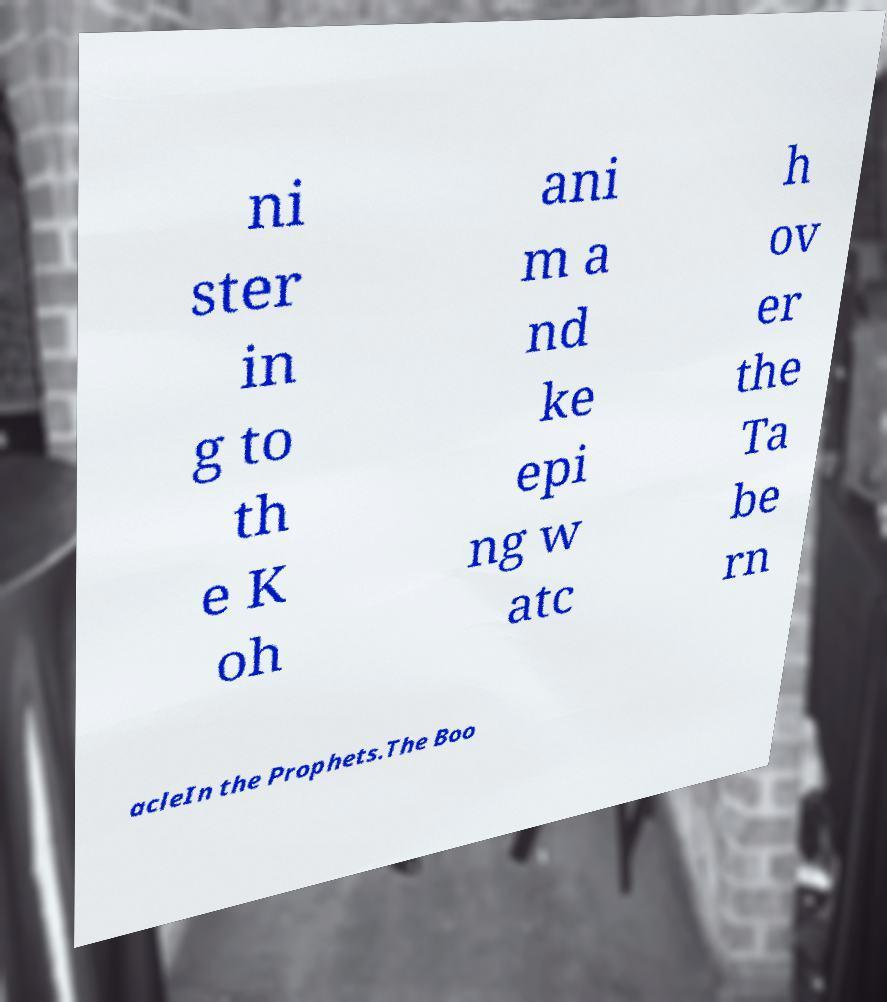What messages or text are displayed in this image? I need them in a readable, typed format. ni ster in g to th e K oh ani m a nd ke epi ng w atc h ov er the Ta be rn acleIn the Prophets.The Boo 